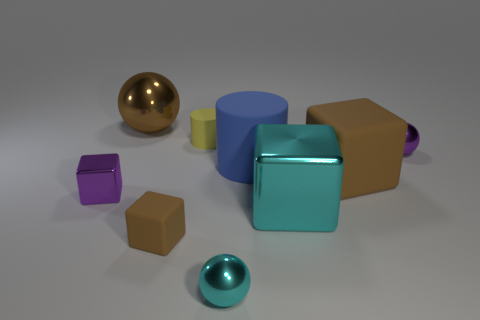The metal block that is right of the tiny cyan metal thing is what color?
Ensure brevity in your answer.  Cyan. What number of other things are there of the same color as the large rubber cylinder?
Provide a short and direct response. 0. Do the metal sphere in front of the blue matte cylinder and the large brown rubber block have the same size?
Your answer should be very brief. No. There is a blue cylinder; how many rubber cubes are behind it?
Keep it short and to the point. 0. Are there any metal balls that have the same size as the blue rubber cylinder?
Your response must be concise. Yes. Is the color of the large matte cylinder the same as the tiny cylinder?
Provide a short and direct response. No. There is a large metallic object behind the small metal sphere that is behind the tiny brown thing; what color is it?
Ensure brevity in your answer.  Brown. What number of objects are both to the right of the cyan cube and behind the big blue object?
Your answer should be compact. 1. How many other matte objects are the same shape as the blue object?
Provide a short and direct response. 1. Do the large ball and the yellow cylinder have the same material?
Your answer should be compact. No. 